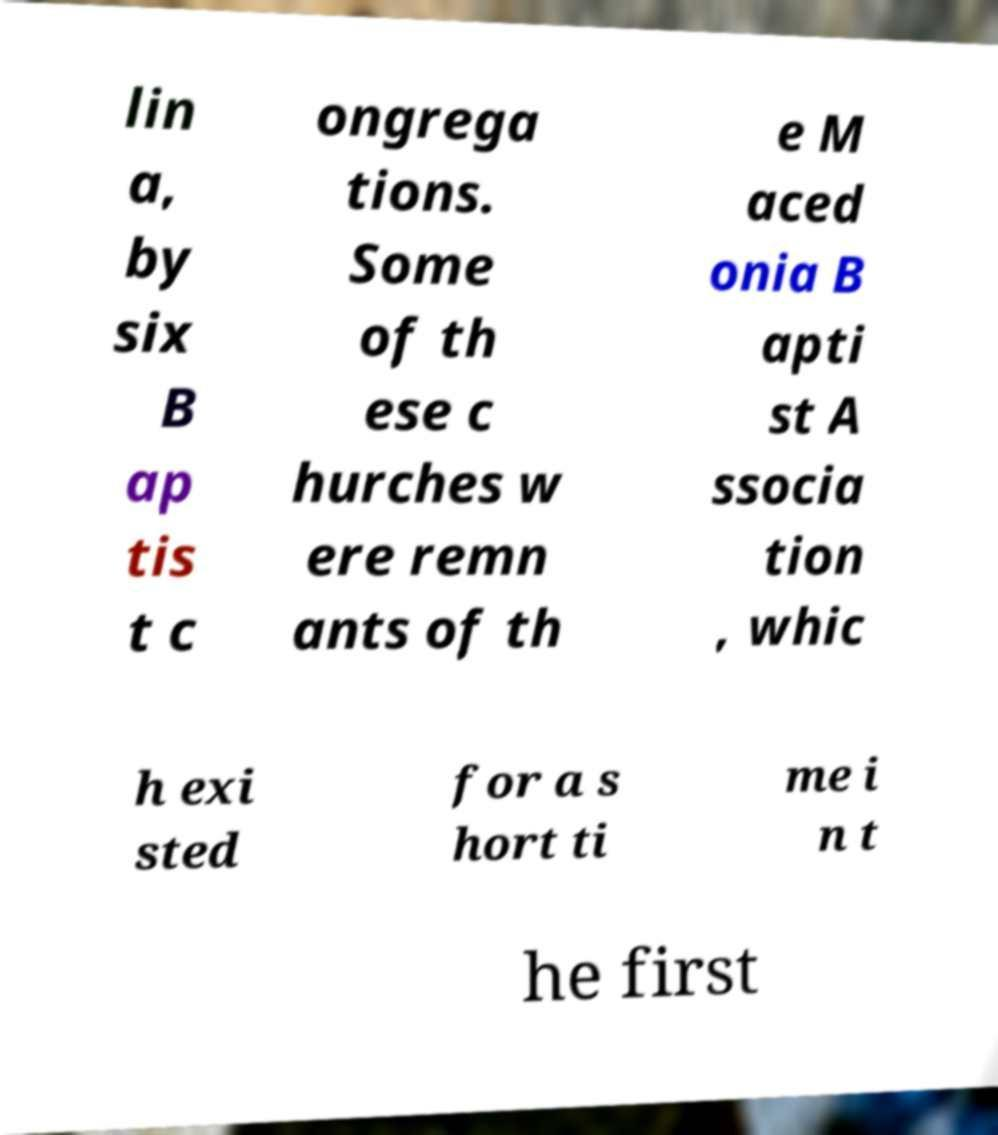What messages or text are displayed in this image? I need them in a readable, typed format. lin a, by six B ap tis t c ongrega tions. Some of th ese c hurches w ere remn ants of th e M aced onia B apti st A ssocia tion , whic h exi sted for a s hort ti me i n t he first 